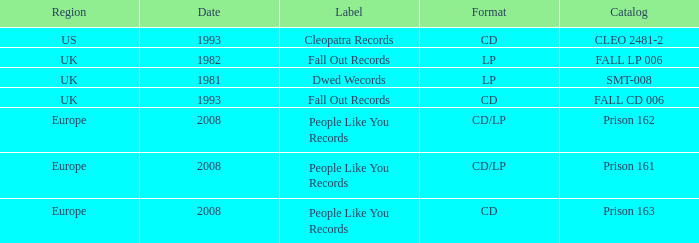Which Label has a Date smaller than 2008, and a Catalog of fall cd 006? Fall Out Records. 